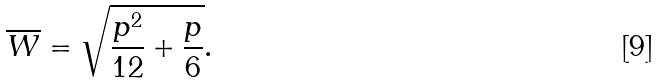Convert formula to latex. <formula><loc_0><loc_0><loc_500><loc_500>\overline { W } = \sqrt { \frac { p ^ { 2 } } { 1 2 } + \frac { p } { 6 } } .</formula> 